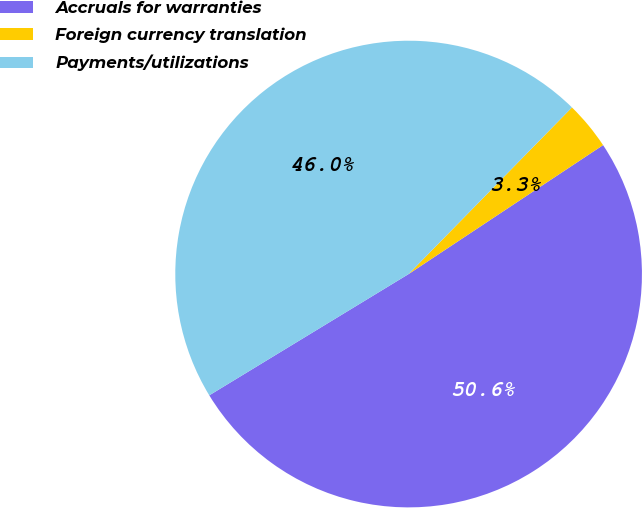<chart> <loc_0><loc_0><loc_500><loc_500><pie_chart><fcel>Accruals for warranties<fcel>Foreign currency translation<fcel>Payments/utilizations<nl><fcel>50.62%<fcel>3.34%<fcel>46.04%<nl></chart> 